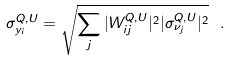<formula> <loc_0><loc_0><loc_500><loc_500>\sigma _ { y _ { i } } ^ { Q , U } = \sqrt { \sum _ { j } | W _ { i j } ^ { Q , U } | ^ { 2 } | \sigma _ { \nu _ { j } } ^ { Q , U } | ^ { 2 } } \ .</formula> 